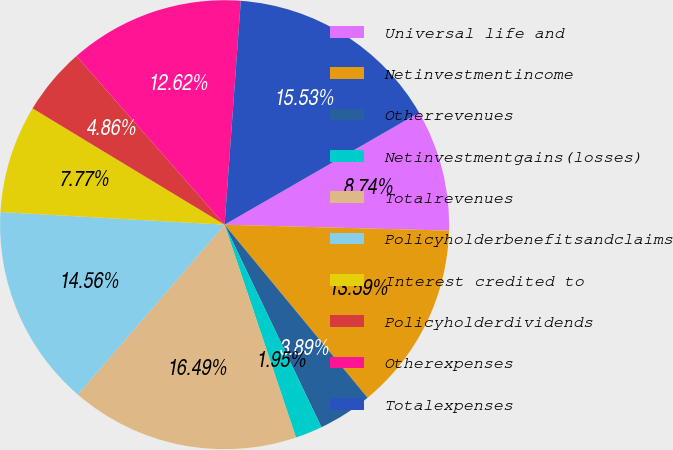Convert chart. <chart><loc_0><loc_0><loc_500><loc_500><pie_chart><fcel>Universal life and<fcel>Netinvestmentincome<fcel>Otherrevenues<fcel>Netinvestmentgains(losses)<fcel>Totalrevenues<fcel>Policyholderbenefitsandclaims<fcel>Interest credited to<fcel>Policyholderdividends<fcel>Otherexpenses<fcel>Totalexpenses<nl><fcel>8.74%<fcel>13.59%<fcel>3.89%<fcel>1.95%<fcel>16.49%<fcel>14.56%<fcel>7.77%<fcel>4.86%<fcel>12.62%<fcel>15.53%<nl></chart> 